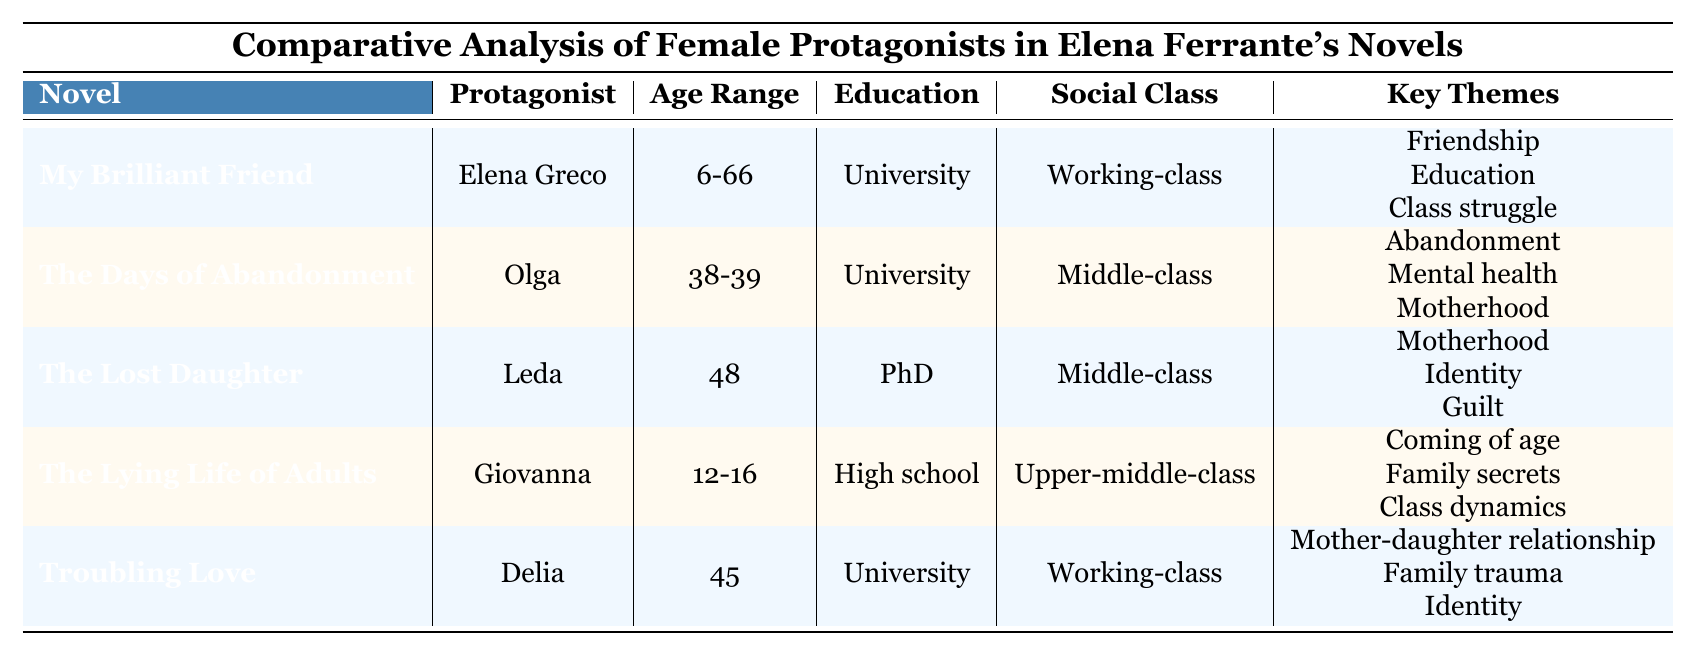What is the age range of the protagonist in "My Brilliant Friend"? The protagonist in "My Brilliant Friend" is Elena Greco, whose age range is listed as 6-66.
Answer: 6-66 How many protagonists have a university education in Ferrante's novels? The table lists three protagonists who have a university education: Elena Greco, Olga, and Delia. Therefore, there are 3 protagonists.
Answer: 3 Is Leda's relationship status divorced? The table shows that Leda's relationship status is listed as divorced, confirming the fact.
Answer: Yes What key themes are shared between "The Days of Abandonment" and "The Lost Daughter"? The key themes for "The Days of Abandonment" are abandonment, mental health, and motherhood, while for "The Lost Daughter," they are motherhood, identity, and guilt. The common theme is motherhood.
Answer: Motherhood Which protagonist is the youngest and what is her age range? The youngest protagonist, Giovanna from "The Lying Life of Adults," has an age range of 12-16. By comparing the age ranges of all protagonists, Giovanna has the youngest range.
Answer: 12-16 How many protagonists are categorized as working-class? There are two protagonists categorized as working-class: Elena Greco from "My Brilliant Friend" and Delia from "Troubling Love."
Answer: 2 Which protagonist has the highest education level and what is it? Leda from "The Lost Daughter" has the highest education level, which is a PhD, making her the most educated protagonist in the table.
Answer: PhD Identify the narrative techniques mentioned in the table. The narrative techniques include first-person narration, stream of consciousness, non-linear storytelling, and intimate psychological exploration, as listed in the appropriate section.
Answer: First-person narration, stream of consciousness, non-linear storytelling, intimate psychological exploration What social class does Giovanna belong to? Giovanna's social class is listed as upper-middle-class in the table, providing the specific classification of her economic status.
Answer: Upper-middle-class Which novel's protagonist is a translator? The protagonist Olga in "The Days of Abandonment" is identified as a translator. Therefore, that is the novel in question.
Answer: The Days of Abandonment 